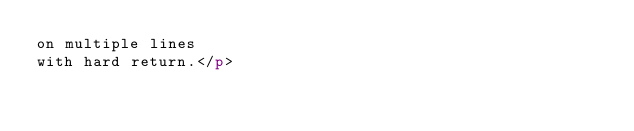<code> <loc_0><loc_0><loc_500><loc_500><_HTML_>on multiple lines
with hard return.</p></code> 